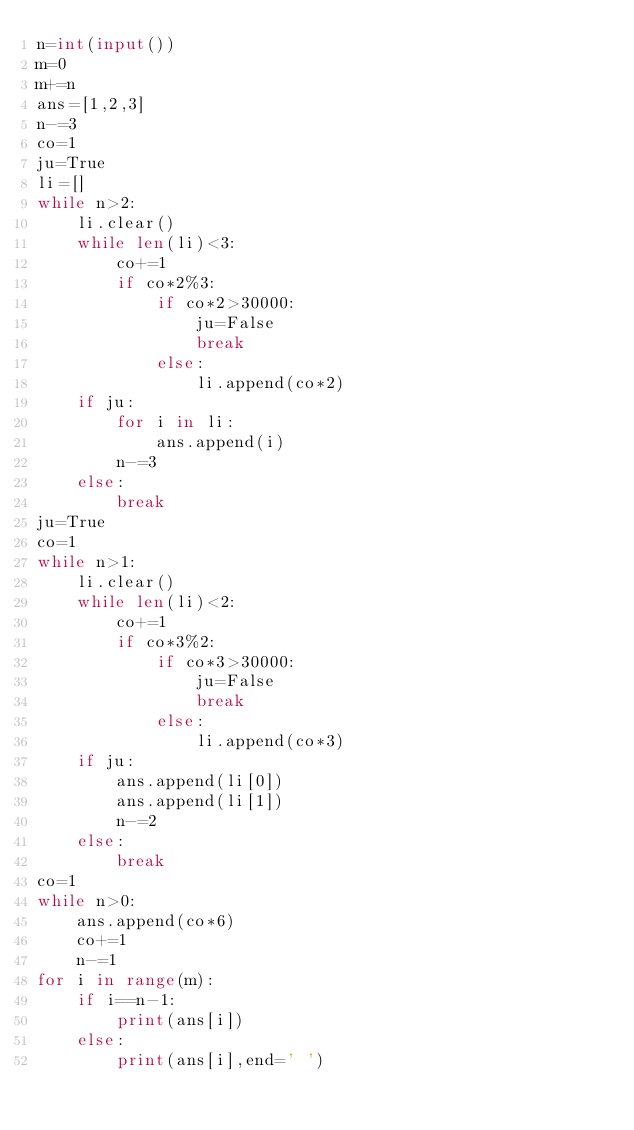Convert code to text. <code><loc_0><loc_0><loc_500><loc_500><_Python_>n=int(input())
m=0
m+=n
ans=[1,2,3]
n-=3
co=1
ju=True
li=[]
while n>2:
    li.clear()
    while len(li)<3:
        co+=1
        if co*2%3:
            if co*2>30000:
                ju=False
                break
            else:
                li.append(co*2)
    if ju:
        for i in li:
            ans.append(i)
        n-=3
    else:
        break
ju=True
co=1
while n>1:
    li.clear()
    while len(li)<2:
        co+=1
        if co*3%2:
            if co*3>30000:
                ju=False
                break
            else:
                li.append(co*3)
    if ju:
        ans.append(li[0])
        ans.append(li[1])
        n-=2
    else:
        break
co=1
while n>0:
    ans.append(co*6)
    co+=1
    n-=1
for i in range(m):
    if i==n-1:
        print(ans[i])
    else:
        print(ans[i],end=' ')
</code> 